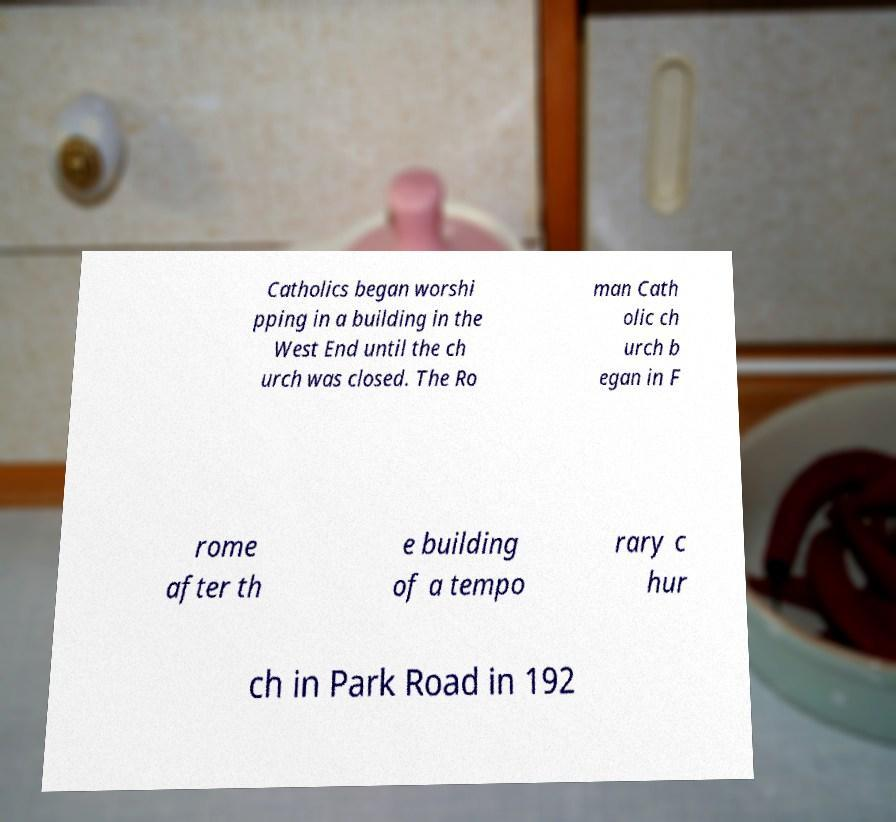Could you assist in decoding the text presented in this image and type it out clearly? Catholics began worshi pping in a building in the West End until the ch urch was closed. The Ro man Cath olic ch urch b egan in F rome after th e building of a tempo rary c hur ch in Park Road in 192 